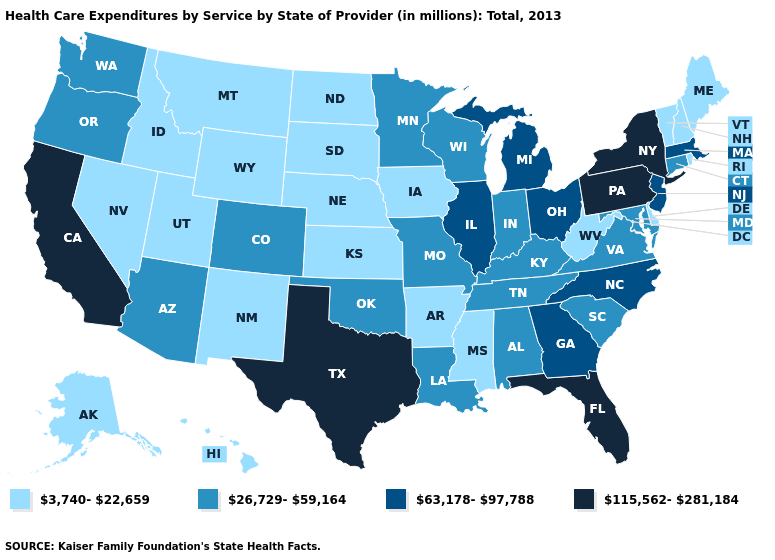Name the states that have a value in the range 115,562-281,184?
Short answer required. California, Florida, New York, Pennsylvania, Texas. What is the lowest value in the South?
Answer briefly. 3,740-22,659. What is the value of Massachusetts?
Short answer required. 63,178-97,788. Which states have the lowest value in the USA?
Concise answer only. Alaska, Arkansas, Delaware, Hawaii, Idaho, Iowa, Kansas, Maine, Mississippi, Montana, Nebraska, Nevada, New Hampshire, New Mexico, North Dakota, Rhode Island, South Dakota, Utah, Vermont, West Virginia, Wyoming. Among the states that border West Virginia , does Virginia have the highest value?
Short answer required. No. What is the value of South Dakota?
Write a very short answer. 3,740-22,659. Does Maryland have the highest value in the USA?
Answer briefly. No. What is the value of Arkansas?
Be succinct. 3,740-22,659. What is the value of Idaho?
Quick response, please. 3,740-22,659. What is the highest value in the Northeast ?
Answer briefly. 115,562-281,184. Does Florida have the highest value in the South?
Quick response, please. Yes. What is the lowest value in states that border Colorado?
Keep it brief. 3,740-22,659. Name the states that have a value in the range 3,740-22,659?
Be succinct. Alaska, Arkansas, Delaware, Hawaii, Idaho, Iowa, Kansas, Maine, Mississippi, Montana, Nebraska, Nevada, New Hampshire, New Mexico, North Dakota, Rhode Island, South Dakota, Utah, Vermont, West Virginia, Wyoming. Name the states that have a value in the range 26,729-59,164?
Keep it brief. Alabama, Arizona, Colorado, Connecticut, Indiana, Kentucky, Louisiana, Maryland, Minnesota, Missouri, Oklahoma, Oregon, South Carolina, Tennessee, Virginia, Washington, Wisconsin. Which states have the highest value in the USA?
Keep it brief. California, Florida, New York, Pennsylvania, Texas. 